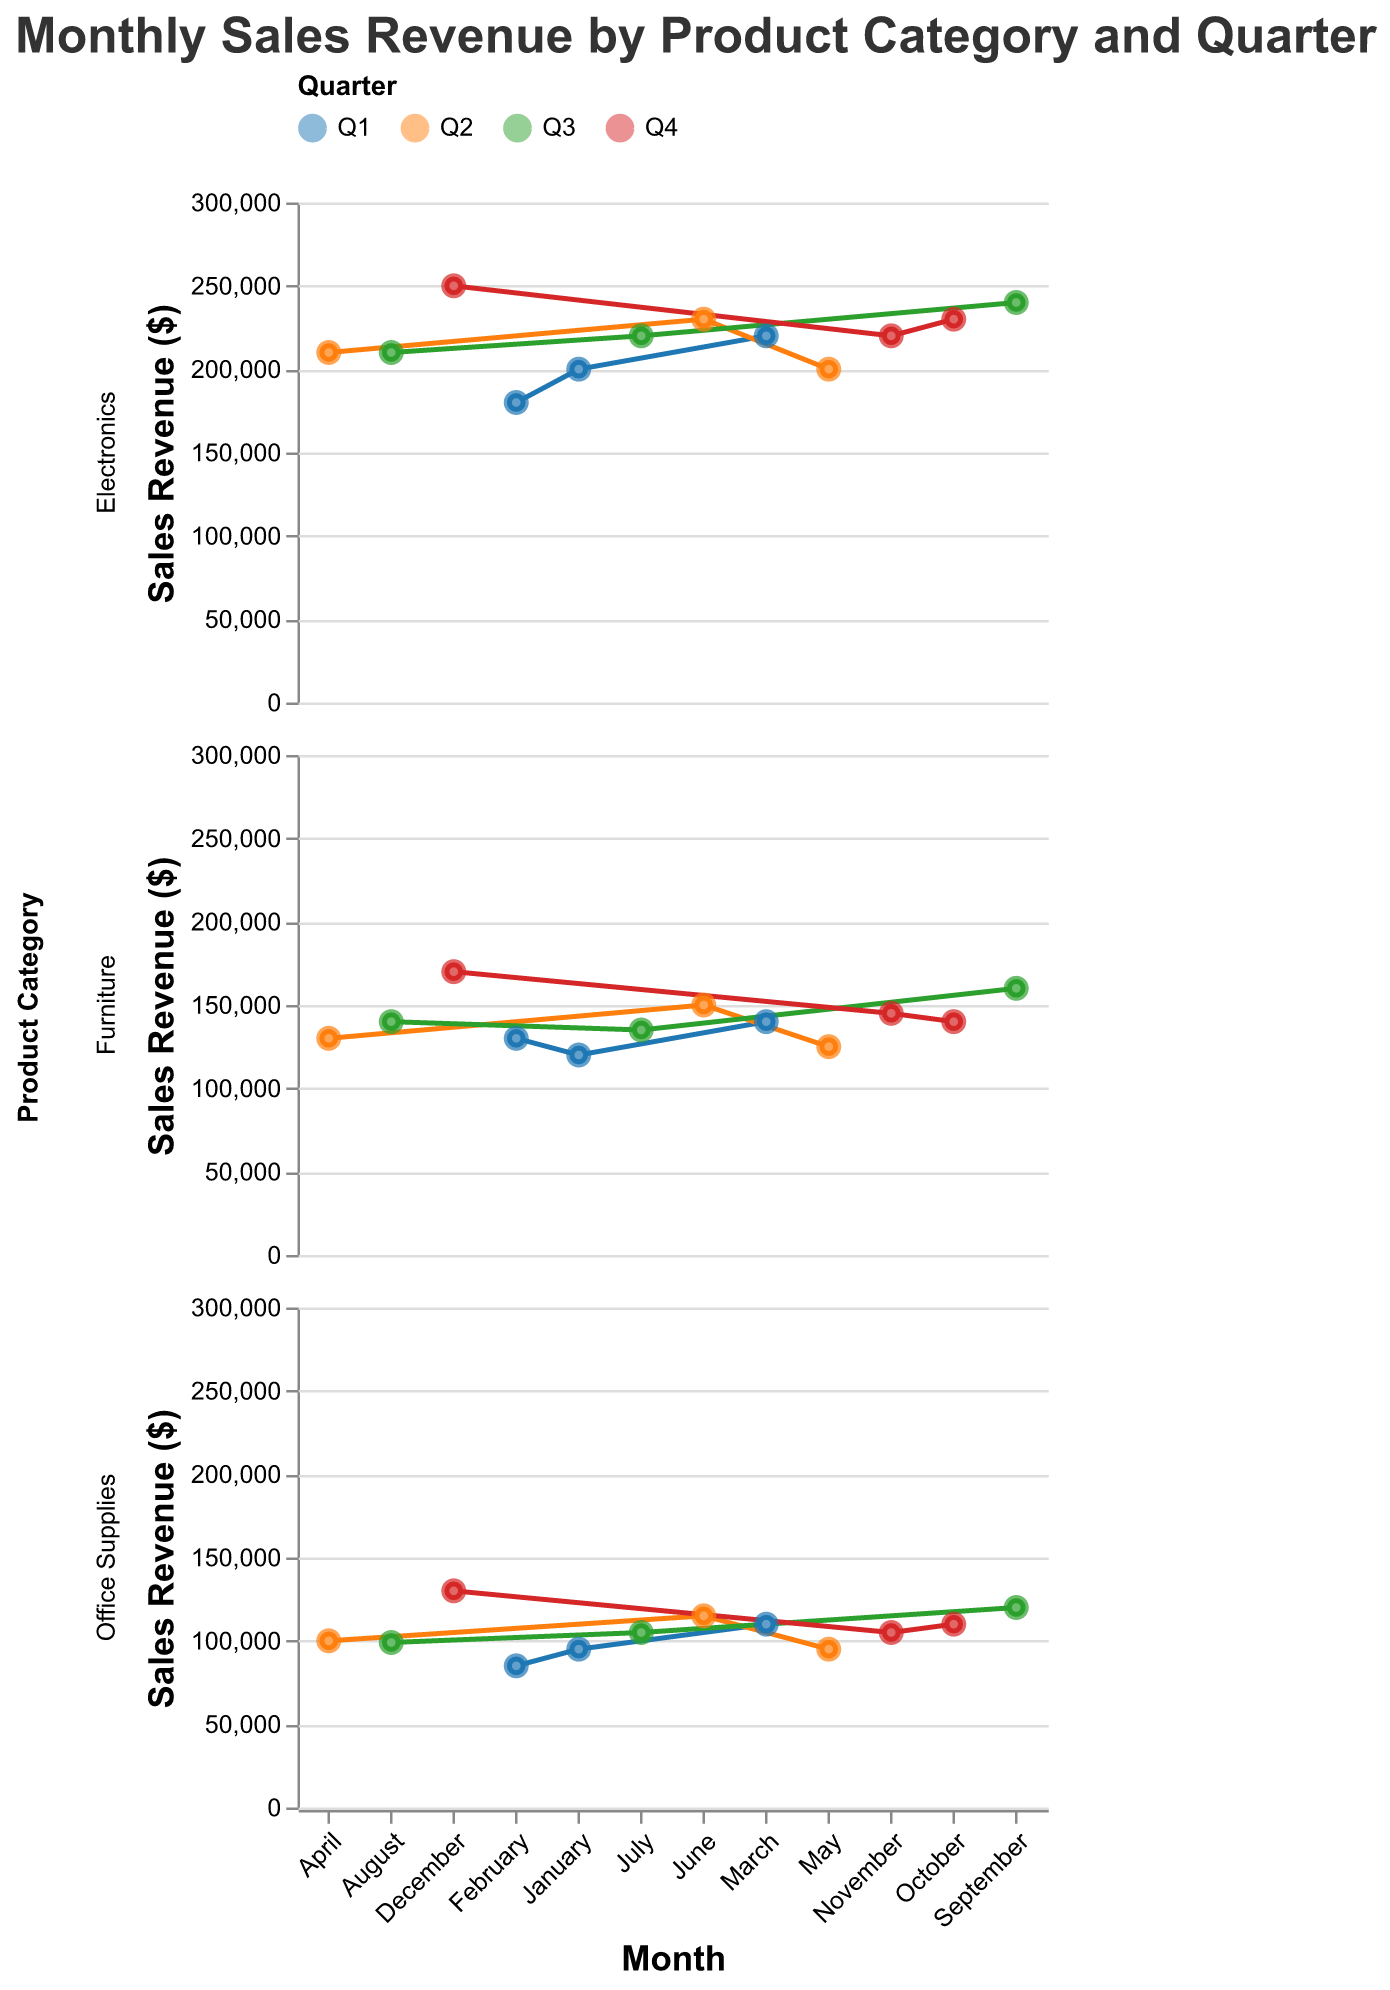Which product category shows the highest sales revenue in December? December sales revenue for each category: Electronics - $250,000, Office Supplies - $130,000, Furniture - $170,000. The highest is Electronics.
Answer: Electronics During which quarter did Office Supplies have the lowest sales revenue in any month? In Q1, Office Supplies' lowest sales revenue was $85,000 in February. In Q2, it was $95,000 in May. In Q3, it was $99,000 in August. In Q4, it was $105,000 in November. The lowest is $85,000 in Q1.
Answer: Q1 What is the total sales revenue for Furniture in Q3? Add Furniture sales revenue in July ($135,000), August ($140,000), and September ($160,000): $135,000 + $140,000 + $160,000 = $435,000
Answer: $435,000 Compare the sales revenue trends for Electronics and Office Supplies across Q1. Which category saw a larger increase from February to March? Electronics: February ($180,000) to March ($220,000) = $40,000 increase. Office Supplies: February ($85,000) to March ($110,000) = $25,000 increase. Electronics had a larger increase.
Answer: Electronics Which month saw the highest sales revenue across all product categories? December saw the highest sales revenue: Electronics - $250,000, Office Supplies - $130,000, Furniture - $170,000. Electronics in December is the highest at $250,000.
Answer: December During which quarter did Electronics see its largest single-month sales revenue? The largest single-month sales revenue for Electronics is $250,000 in December (Q4).
Answer: Q4 What is the average sales revenue for Office Supplies in Q2? Add Office Supplies sales for April ($100,000), May ($95,000), and June ($115,000). Divide by 3: ($100,000 + $95,000 + $115,000) / 3 = $310,000 / 3 = $103,333.33
Answer: $103,333.33 Which product category shows more stable sales across all quarters, Furniture or Office Supplies? Compare the visual fluctuation of the sales revenue lines for Furniture and Office Supplies. Furniture's lines are more stable as they fluctuate less compared to Office Supplies.
Answer: Furniture 